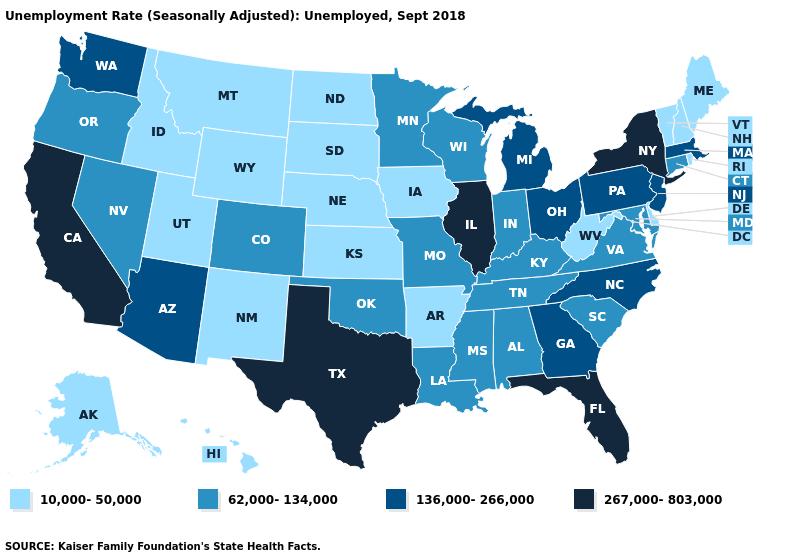Which states hav the highest value in the MidWest?
Be succinct. Illinois. What is the value of North Carolina?
Short answer required. 136,000-266,000. What is the value of Alaska?
Give a very brief answer. 10,000-50,000. What is the value of Nevada?
Concise answer only. 62,000-134,000. Name the states that have a value in the range 136,000-266,000?
Concise answer only. Arizona, Georgia, Massachusetts, Michigan, New Jersey, North Carolina, Ohio, Pennsylvania, Washington. What is the value of Louisiana?
Short answer required. 62,000-134,000. What is the value of Wisconsin?
Quick response, please. 62,000-134,000. Does the first symbol in the legend represent the smallest category?
Quick response, please. Yes. What is the value of Nevada?
Give a very brief answer. 62,000-134,000. What is the lowest value in the West?
Give a very brief answer. 10,000-50,000. Does Utah have the highest value in the West?
Give a very brief answer. No. Name the states that have a value in the range 62,000-134,000?
Be succinct. Alabama, Colorado, Connecticut, Indiana, Kentucky, Louisiana, Maryland, Minnesota, Mississippi, Missouri, Nevada, Oklahoma, Oregon, South Carolina, Tennessee, Virginia, Wisconsin. What is the value of Louisiana?
Concise answer only. 62,000-134,000. What is the value of Montana?
Give a very brief answer. 10,000-50,000. Which states have the highest value in the USA?
Write a very short answer. California, Florida, Illinois, New York, Texas. 